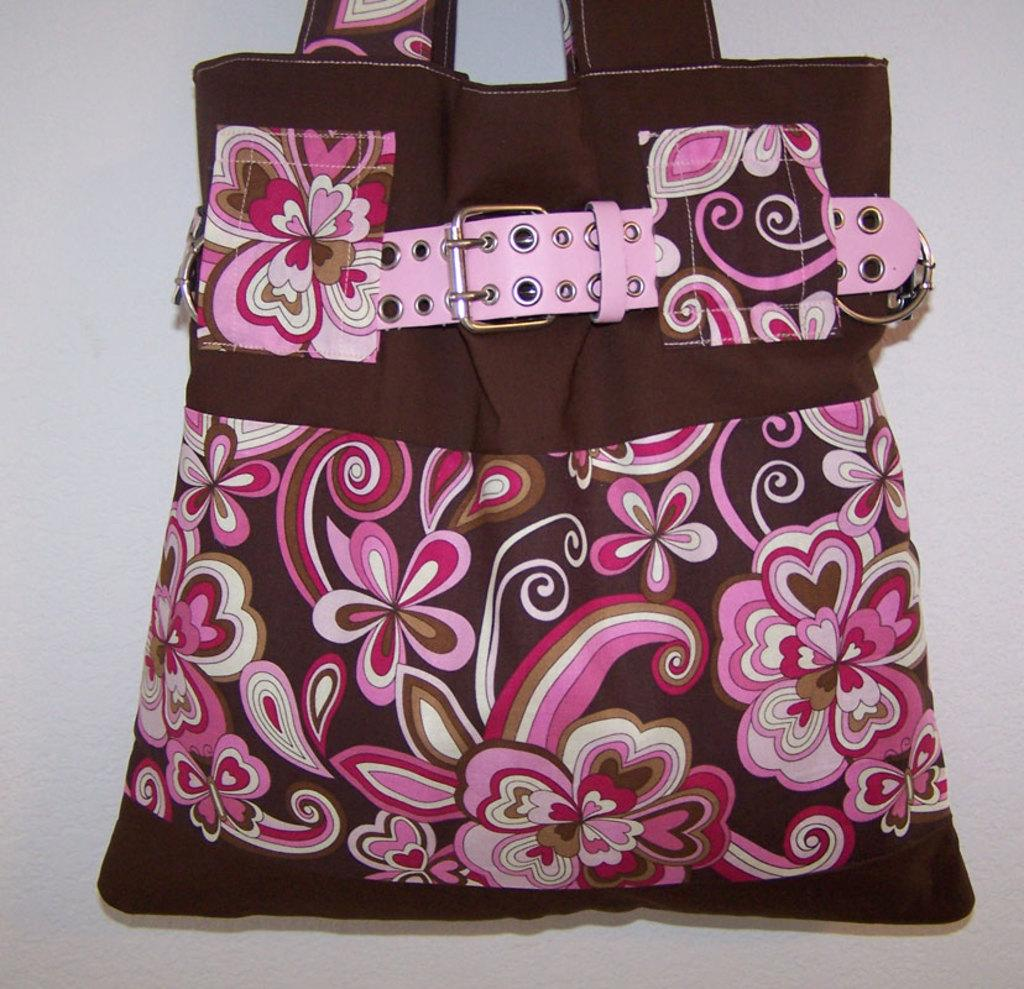What object is present in the image? There is a bag in the image. What type of stage is visible in the image? There is no stage present in the image; it only features a bag. What letters are written on the bag in the image? The provided facts do not mention any letters on the bag, so we cannot answer this question definitively. 